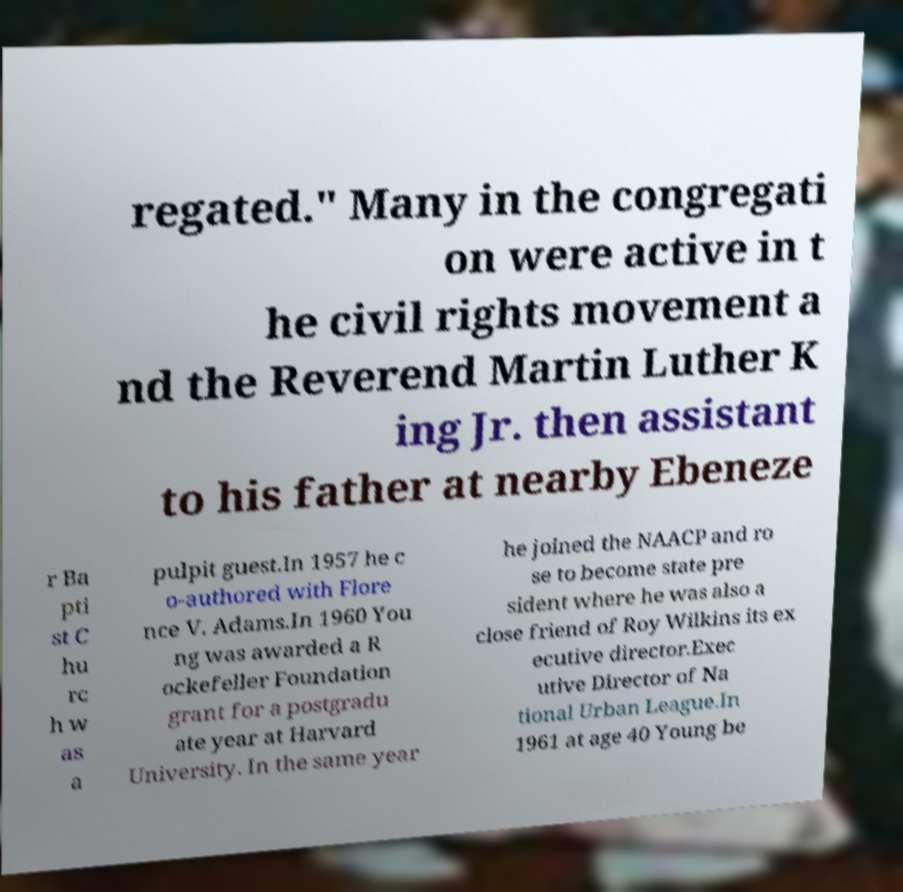I need the written content from this picture converted into text. Can you do that? regated." Many in the congregati on were active in t he civil rights movement a nd the Reverend Martin Luther K ing Jr. then assistant to his father at nearby Ebeneze r Ba pti st C hu rc h w as a pulpit guest.In 1957 he c o-authored with Flore nce V. Adams.In 1960 You ng was awarded a R ockefeller Foundation grant for a postgradu ate year at Harvard University. In the same year he joined the NAACP and ro se to become state pre sident where he was also a close friend of Roy Wilkins its ex ecutive director.Exec utive Director of Na tional Urban League.In 1961 at age 40 Young be 